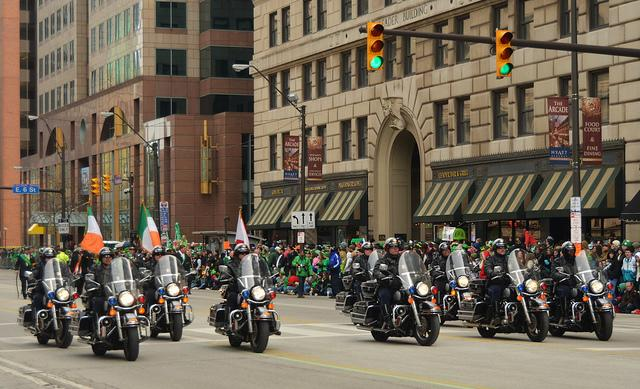Which nation is the motorcade of police motorcycles celebrating? ireland 